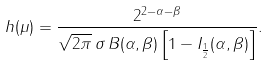Convert formula to latex. <formula><loc_0><loc_0><loc_500><loc_500>h ( \mu ) = \frac { 2 ^ { 2 - \alpha - \beta } } { \sqrt { 2 \pi } \, \sigma \, B ( \alpha , \beta ) \left [ 1 - I _ { \frac { 1 } { 2 } } ( \alpha , \beta ) \right ] } .</formula> 